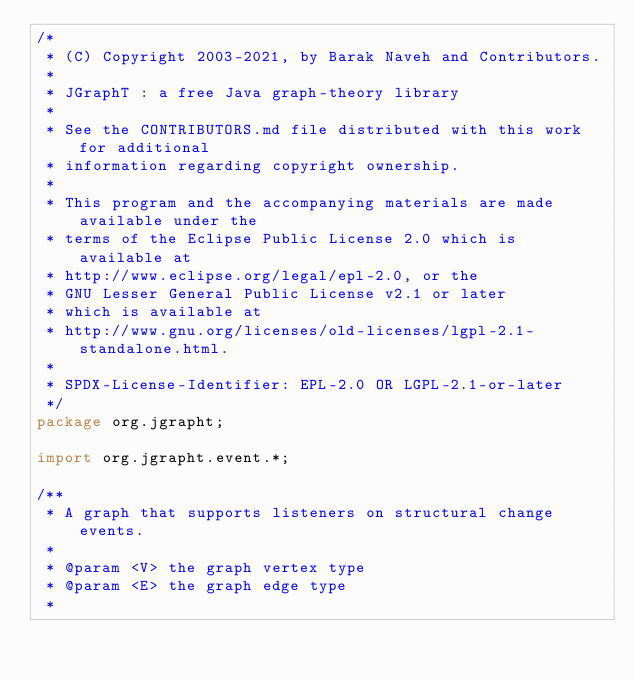Convert code to text. <code><loc_0><loc_0><loc_500><loc_500><_Java_>/*
 * (C) Copyright 2003-2021, by Barak Naveh and Contributors.
 *
 * JGraphT : a free Java graph-theory library
 *
 * See the CONTRIBUTORS.md file distributed with this work for additional
 * information regarding copyright ownership.
 *
 * This program and the accompanying materials are made available under the
 * terms of the Eclipse Public License 2.0 which is available at
 * http://www.eclipse.org/legal/epl-2.0, or the
 * GNU Lesser General Public License v2.1 or later
 * which is available at
 * http://www.gnu.org/licenses/old-licenses/lgpl-2.1-standalone.html.
 *
 * SPDX-License-Identifier: EPL-2.0 OR LGPL-2.1-or-later
 */
package org.jgrapht;

import org.jgrapht.event.*;

/**
 * A graph that supports listeners on structural change events.
 *
 * @param <V> the graph vertex type
 * @param <E> the graph edge type
 * </code> 